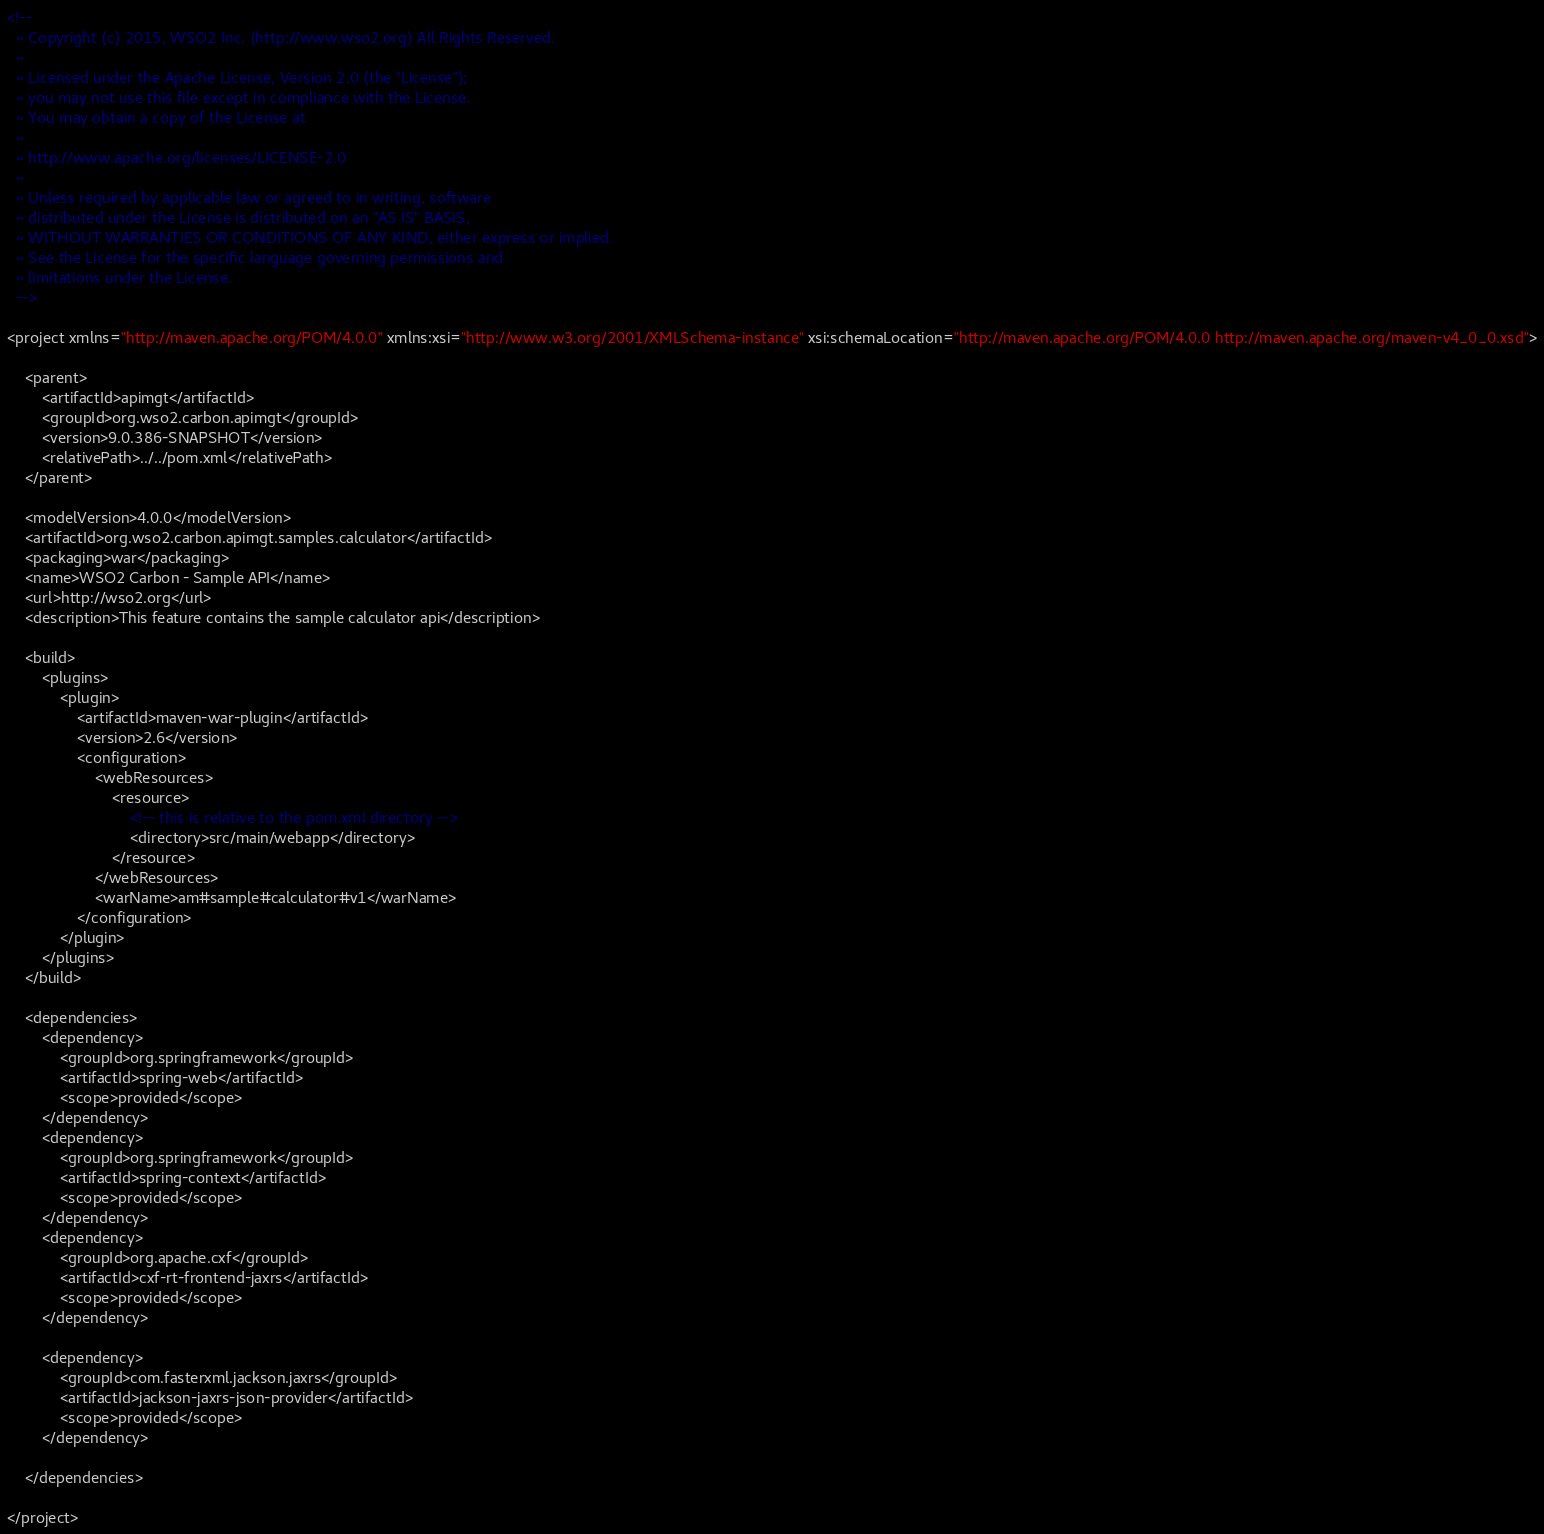<code> <loc_0><loc_0><loc_500><loc_500><_XML_><!--
  ~ Copyright (c) 2015, WSO2 Inc. (http://www.wso2.org) All Rights Reserved.
  ~
  ~ Licensed under the Apache License, Version 2.0 (the "License");
  ~ you may not use this file except in compliance with the License.
  ~ You may obtain a copy of the License at
  ~
  ~ http://www.apache.org/licenses/LICENSE-2.0
  ~
  ~ Unless required by applicable law or agreed to in writing, software
  ~ distributed under the License is distributed on an "AS IS" BASIS,
  ~ WITHOUT WARRANTIES OR CONDITIONS OF ANY KIND, either express or implied.
  ~ See the License for the specific language governing permissions and
  ~ limitations under the License.
  -->

<project xmlns="http://maven.apache.org/POM/4.0.0" xmlns:xsi="http://www.w3.org/2001/XMLSchema-instance" xsi:schemaLocation="http://maven.apache.org/POM/4.0.0 http://maven.apache.org/maven-v4_0_0.xsd">

    <parent>
        <artifactId>apimgt</artifactId>
        <groupId>org.wso2.carbon.apimgt</groupId>
        <version>9.0.386-SNAPSHOT</version>
        <relativePath>../../pom.xml</relativePath>
    </parent>

    <modelVersion>4.0.0</modelVersion>
    <artifactId>org.wso2.carbon.apimgt.samples.calculator</artifactId>
    <packaging>war</packaging>
    <name>WSO2 Carbon - Sample API</name>
    <url>http://wso2.org</url>
    <description>This feature contains the sample calculator api</description>

    <build>
        <plugins>
            <plugin>
                <artifactId>maven-war-plugin</artifactId>
                <version>2.6</version>
                <configuration>
                    <webResources>
                        <resource>
                            <!-- this is relative to the pom.xml directory -->
                            <directory>src/main/webapp</directory>
                        </resource>
                    </webResources>
                    <warName>am#sample#calculator#v1</warName>
                </configuration>
            </plugin>
        </plugins>
    </build>

    <dependencies>
        <dependency>
            <groupId>org.springframework</groupId>
            <artifactId>spring-web</artifactId>
            <scope>provided</scope>
        </dependency>
        <dependency>
            <groupId>org.springframework</groupId>
            <artifactId>spring-context</artifactId>
            <scope>provided</scope>
        </dependency>
        <dependency>
            <groupId>org.apache.cxf</groupId>
            <artifactId>cxf-rt-frontend-jaxrs</artifactId>
            <scope>provided</scope>
        </dependency>

        <dependency>
            <groupId>com.fasterxml.jackson.jaxrs</groupId>
            <artifactId>jackson-jaxrs-json-provider</artifactId>
            <scope>provided</scope>
        </dependency>

    </dependencies>

</project>
</code> 